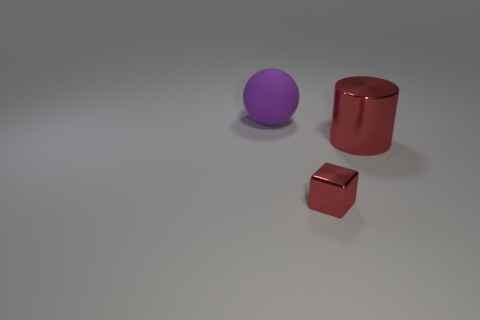Judging by the image, what time of day or lighting condition does this seem to represent? The image likely depicts an indoor setting with controlled lighting rather than a natural environment, as the shadows are sharp and there is a lack of environment-specific cues like a sky or surrounding objects to indicate the time of day. 